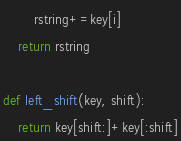<code> <loc_0><loc_0><loc_500><loc_500><_Python_>        rstring+=key[i]
    return rstring

def left_shift(key, shift):
    return key[shift:]+key[:shift]
</code> 